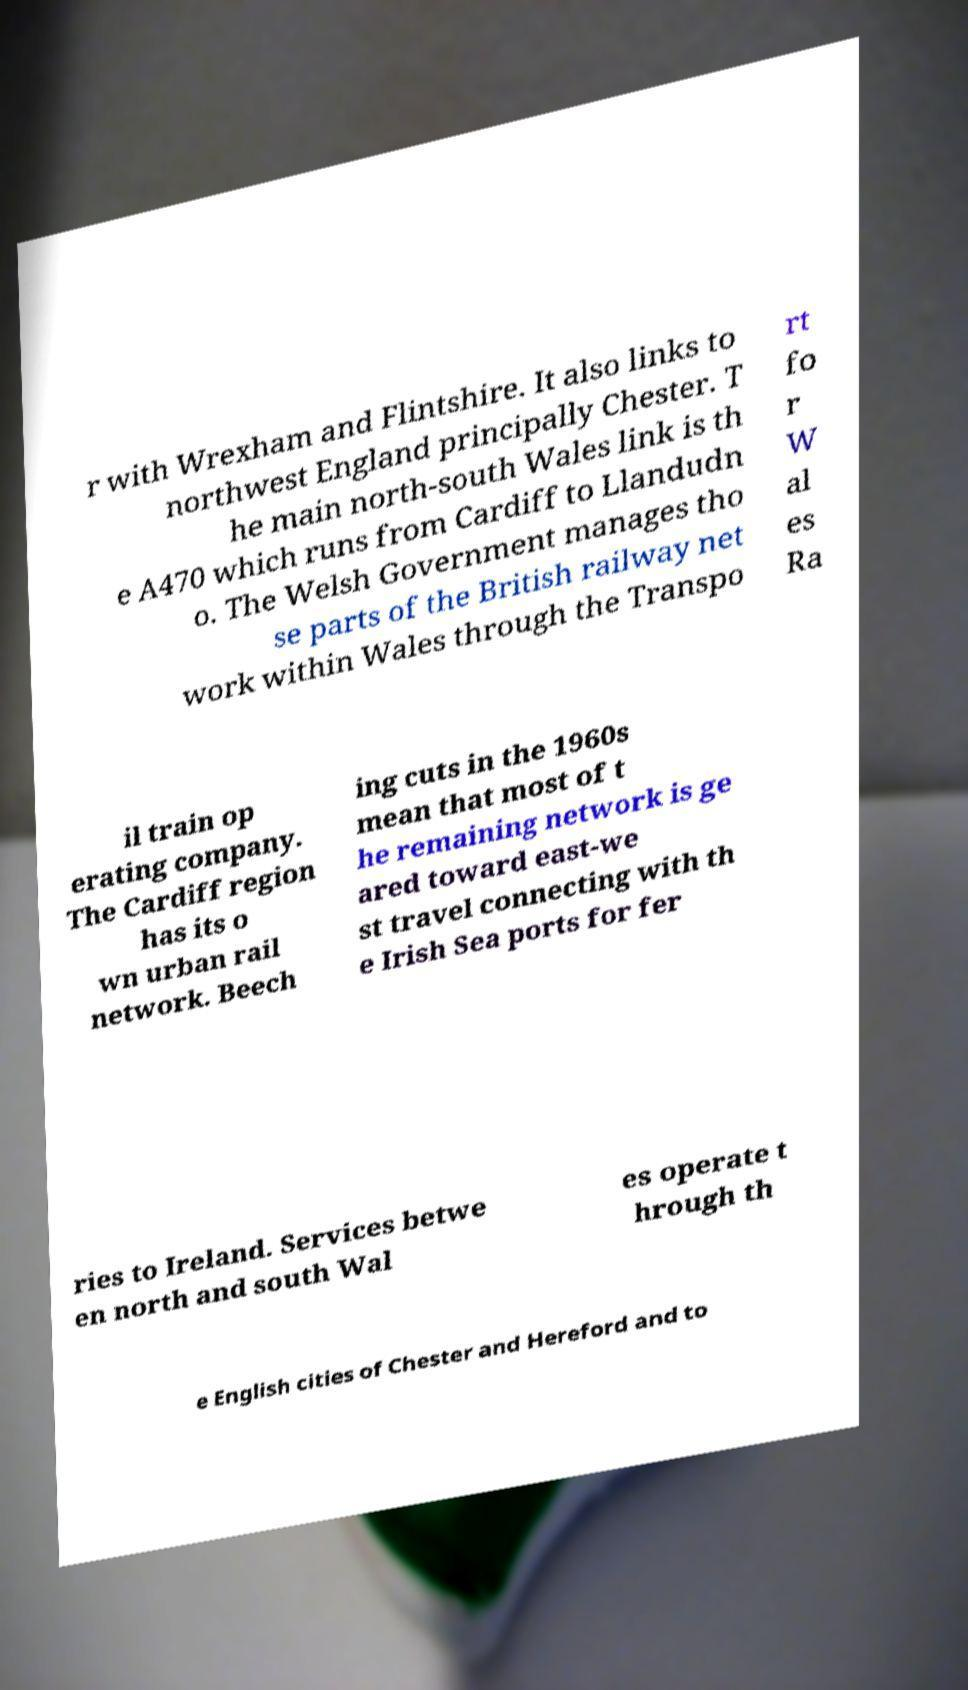Can you read and provide the text displayed in the image?This photo seems to have some interesting text. Can you extract and type it out for me? r with Wrexham and Flintshire. It also links to northwest England principally Chester. T he main north-south Wales link is th e A470 which runs from Cardiff to Llandudn o. The Welsh Government manages tho se parts of the British railway net work within Wales through the Transpo rt fo r W al es Ra il train op erating company. The Cardiff region has its o wn urban rail network. Beech ing cuts in the 1960s mean that most of t he remaining network is ge ared toward east-we st travel connecting with th e Irish Sea ports for fer ries to Ireland. Services betwe en north and south Wal es operate t hrough th e English cities of Chester and Hereford and to 